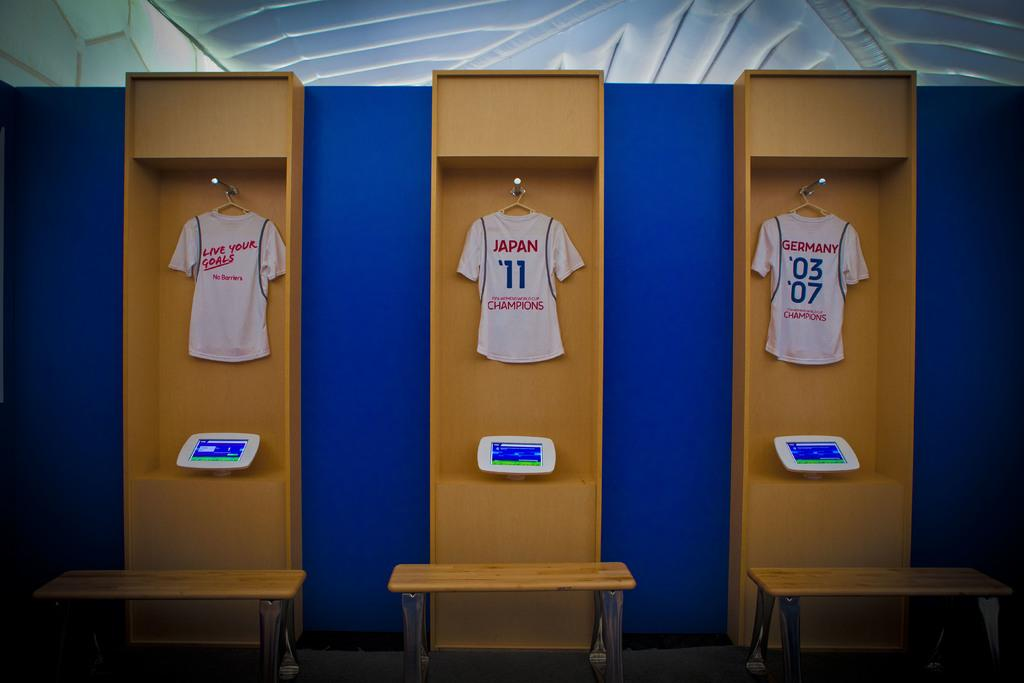What type of furniture is present in the image? There is furniture with screens in the image. What items are hanging on the furniture? T-shirts are hanging on hangers in the image. What is located in front of the furniture? There are tables in front of the furniture. What can be seen in the background of the image? There is a wall visible in the background of the image. What type of authority is depicted in the image? There is no authority figure present in the image; it features furniture, T-shirts, tables, and a wall. How does the wind blow the T-shirts in the image? There is no wind blowing the T-shirts in the image; they are hanging on hangers. 